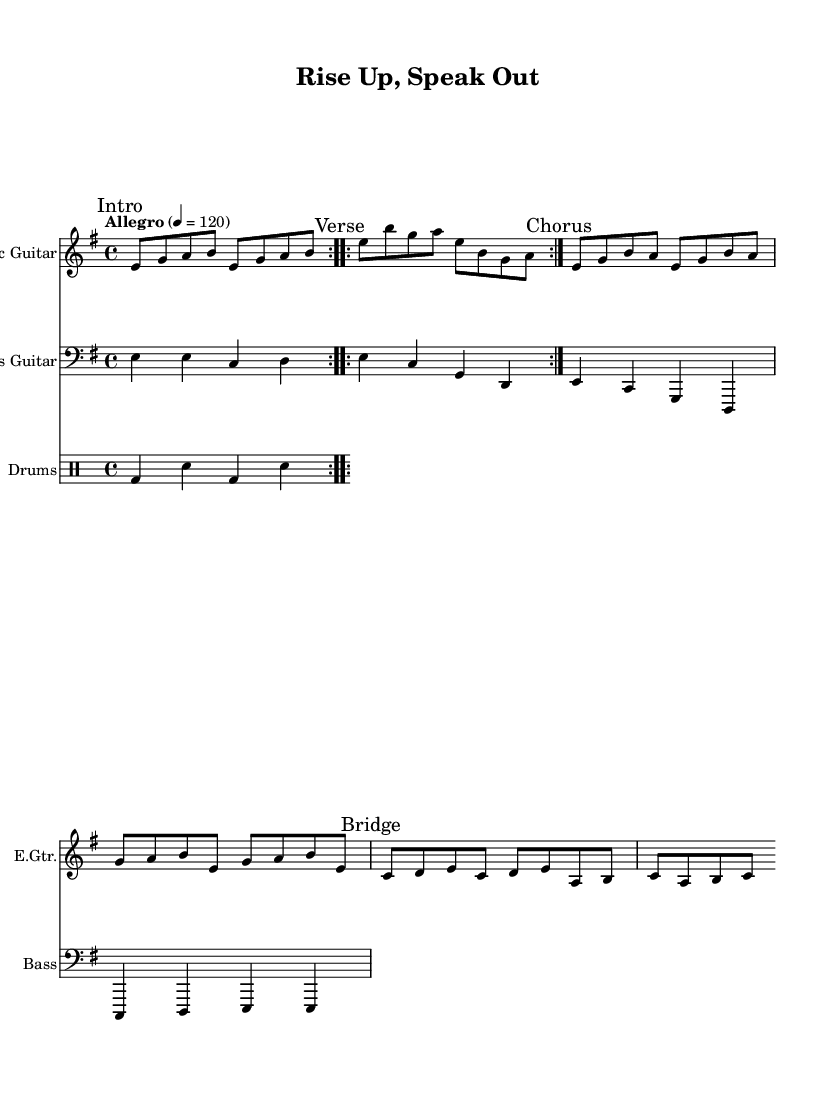What is the key signature of this music? The key signature indicated in the music sheet is E minor, which has one sharp (F#). This can be determined by checking the first part of the score where the key signature is placed.
Answer: E minor What is the time signature of this music? The time signature shown in the music is 4/4, which means there are four beats in a measure. This can be found at the beginning of the score where the time is indicated.
Answer: 4/4 What is the tempo marking for this piece? The tempo marking indicates "Allegro" at a speed of 120 beats per minute. This information is typically placed at the beginning of the notation and indicates how fast the piece should be played.
Answer: Allegro, 120 How many measures are in the intro section? To find the number of measures in the intro, we count the measures outlined for this section in the electric guitar part. The intro has two measures that repeat, totaling four measures.
Answer: 4 What instrument plays the bridge section? The bridge section is played by the electric guitar, as specified by the part markings. In this case, all sections of music written for the electric guitar are understood to incorporate the bridge section.
Answer: Electric Guitar What is the structure of the song in terms of sections? The song consists of an "Intro," "Verse," "Chorus," and "Bridge," making up its overall structure. This can be derived from the distinct section markings provided in the sheet music.
Answer: Intro, Verse, Chorus, Bridge How many instruments are part of this score? The score includes three instruments: Electric Guitar, Bass Guitar, and Drums. Each instrument's part is identified independently within the score.
Answer: 3 